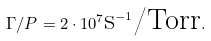Convert formula to latex. <formula><loc_0><loc_0><loc_500><loc_500>\Gamma / P = 2 \cdot 1 0 ^ { 7 } { \text {s} } ^ { - 1 } { \text {/Torr} } .</formula> 